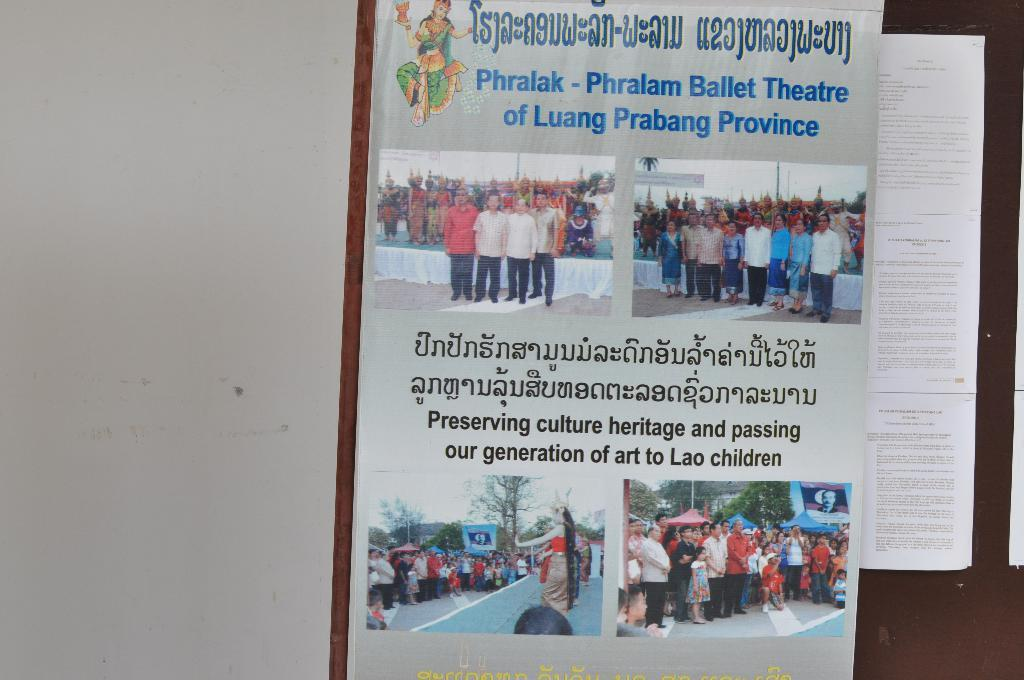What can be seen on the right side of the image? There is a board on the right side of the image. What is attached to the board? Papers and a poster are present on the board. What is depicted on the poster? People are depicted on the poster. What else is featured on the poster besides the image? There is text on the poster. What is on the left side of the image? There is a wall on the left side of the image. What type of oatmeal is being used as fuel for the people depicted on the poster? There is no oatmeal or fuel mentioned in the image, and the people depicted on the poster are not associated with any fuel or oatmeal. What type of teeth can be seen on the people depicted on the poster? There are no teeth visible on the people depicted on the poster, as the image does not show any close-up or detailed view of their faces. 